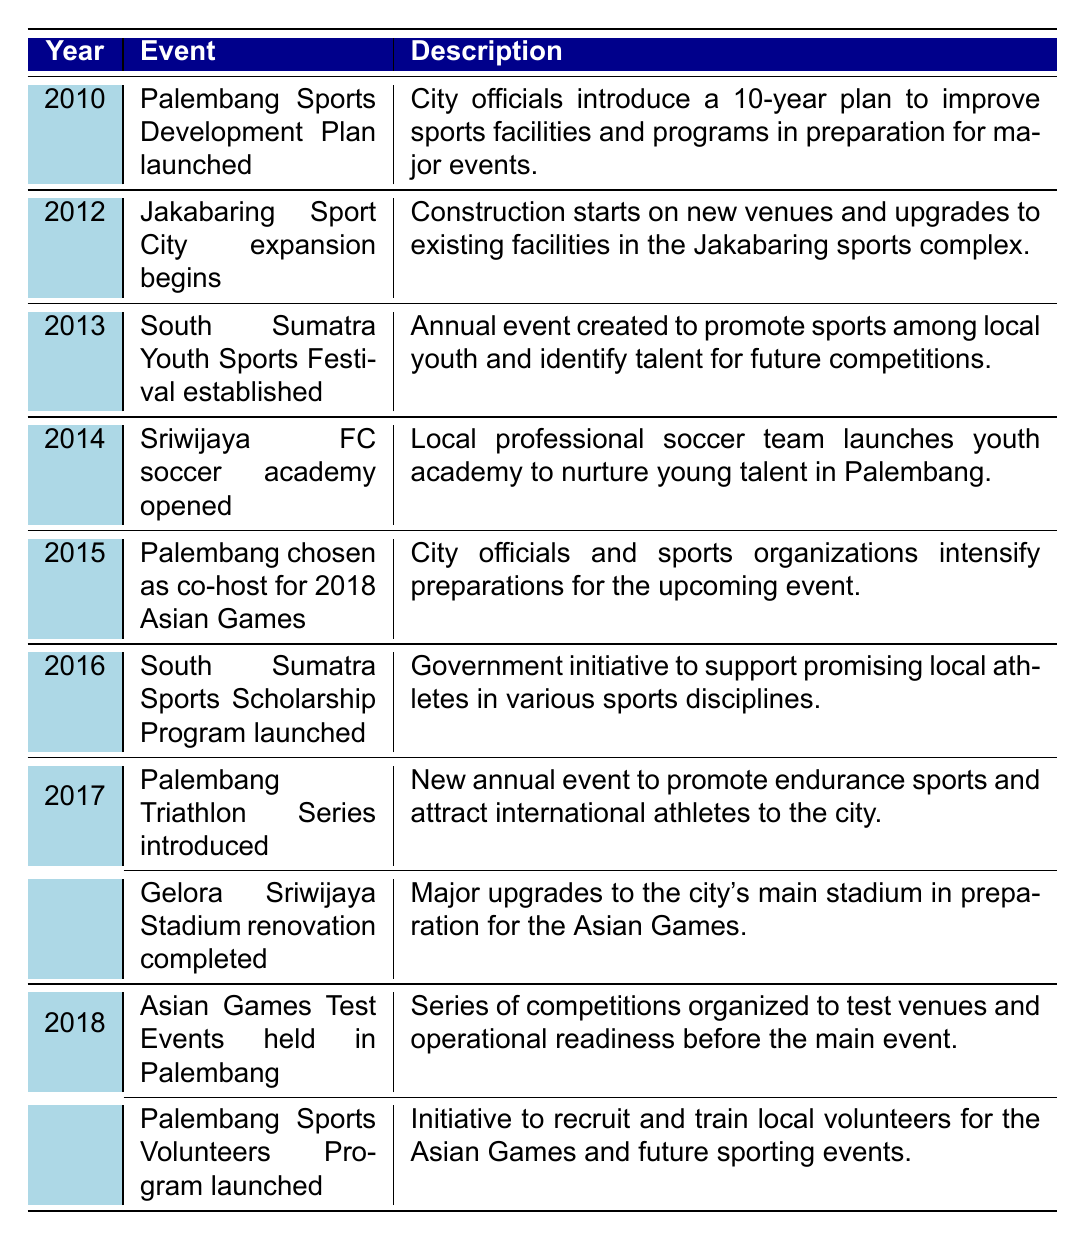What significant sports development initiative was launched in Palembang in 2010? The table indicates that the "Palembang Sports Development Plan" was launched in 2010. This initiative aimed to improve sports facilities and programs over a ten-year period in preparation for major events.
Answer: Palembang Sports Development Plan What event marks the beginning of construction at the Jakabaring Sports City? According to the table, the "Jakabaring Sport City expansion begins" in 2012 marks the commencement of construction for new venues and upgrades to existing facilities.
Answer: Jakabaring Sport City expansion begins Which initiative was aimed at supporting promising local athletes and when was it launched? The "South Sumatra Sports Scholarship Program" was launched in 2016, as per the table. This initiative was designed to support local athletes showing promise in various sports disciplines.
Answer: South Sumatra Sports Scholarship Program launched in 2016 How many events were held in 2018 related to the Asian Games? There were two events listed for 2018: "Asian Games Test Events held in Palembang" and "Palembang Sports Volunteers Program launched." This means that there are two significant activities related to the Asian Games.
Answer: Two events Was there an establishment aimed at youth sports in 2013? Yes, the table shows that the "South Sumatra Youth Sports Festival" was established in 2013. This annual event encourages sports among local youth and helps identify future talent for competitions.
Answer: Yes What was completed in 2017 to prepare for the Asian Games? The "Gelora Sriwijaya Stadium renovation" was completed in 2017, according to the table. This renovation involved major upgrades to the main stadium in Palembang to ensure it was ready for the Asian Games.
Answer: Gelora Sriwijaya Stadium renovation completed What series of operations was executed in 2018 prior to the Asian Games main event? The "Asian Games Test Events held in Palembang" occurred in 2018, which included a series of competitions. These were organized to test the venues and the operational readiness of the event before its main occurrence.
Answer: Asian Games Test Events held What initiative was launched in 2018 to involve the local community in sports events? The "Palembang Sports Volunteers Program" was launched in 2018, as indicated in the table. This initiative focused on recruiting and training local volunteers for both the Asian Games and future sports events.
Answer: Palembang Sports Volunteers Program launched In what year did Palembang become a co-host for the Asian Games, and what was a direct consequence of this? In 2015, Palembang was chosen as a co-host for the 2018 Asian Games, leading to intensified preparations from city officials and sports organizations for the upcoming event.
Answer: 2015; intensified preparations How many years passed between the launch of the Sports Development Plan in 2010 and the initiation of the Sports Scholarship Program in 2016? The difference between the two years is 2016 - 2010 = 6 years. This indicates a six-year span during which various sports initiatives developed before the scholarship program launched.
Answer: 6 years 